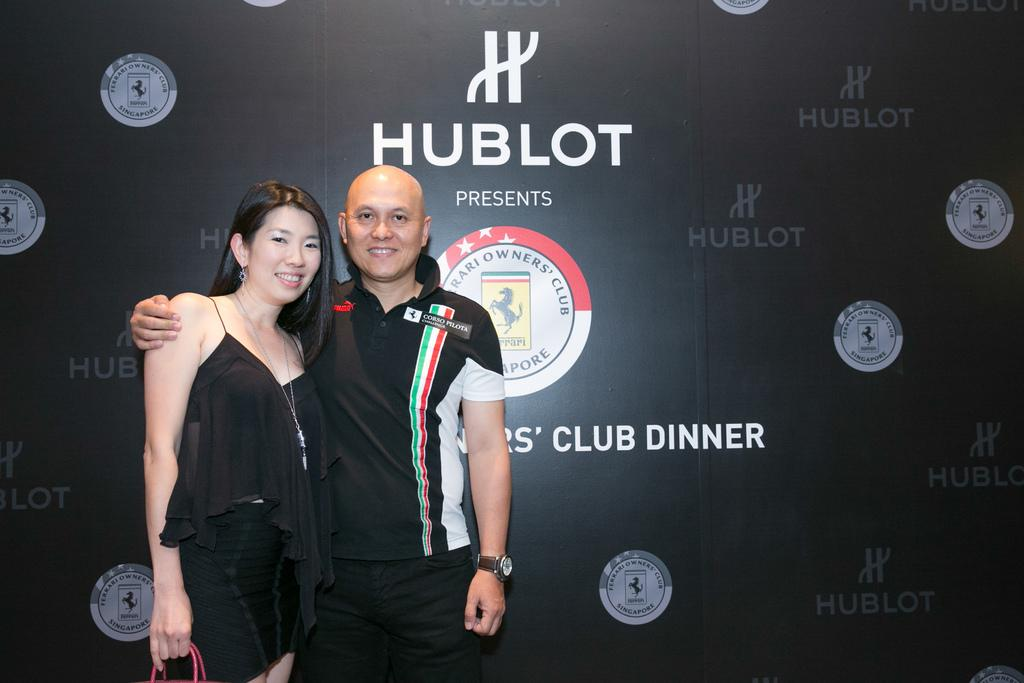<image>
Render a clear and concise summary of the photo. A man and woman are standing in front of a sign that reads Hublot. 